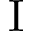Convert formula to latex. <formula><loc_0><loc_0><loc_500><loc_500>I</formula> 